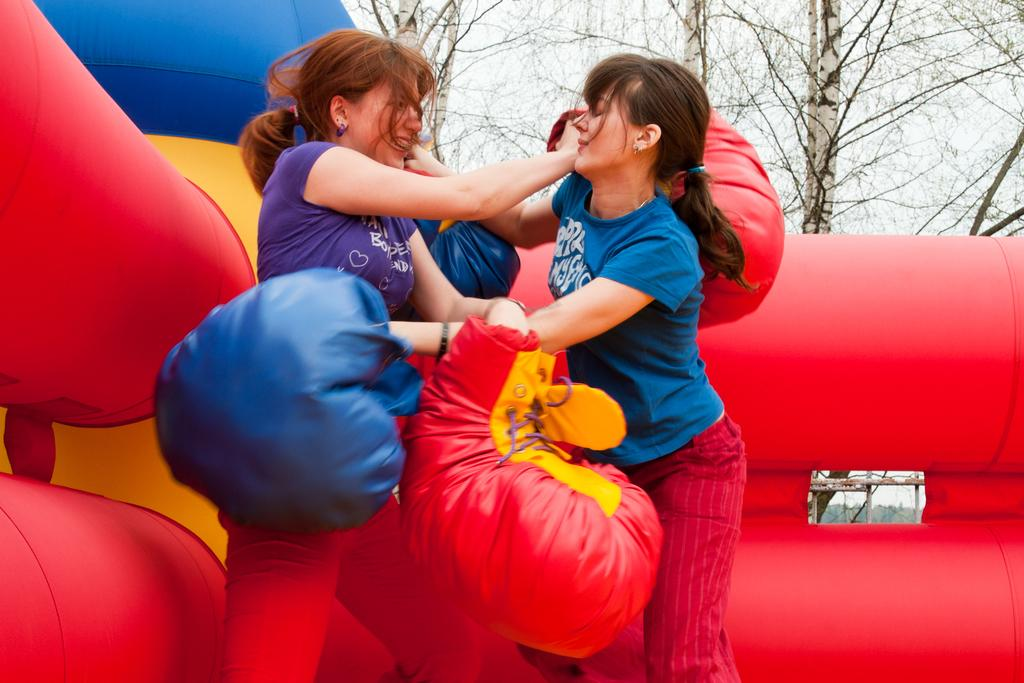How many women are present in the image? There are two women in the image. What are the women holding in the image? The women are holding objects in the image. What type of objects can be seen in the image besides the ones held by the women? There are inflatable objects in the image. What can be seen in the background of the image? There are trees and the sky visible in the background of the image. What type of silk is draped over the shelf in the image? There is no shelf or silk present in the image. 